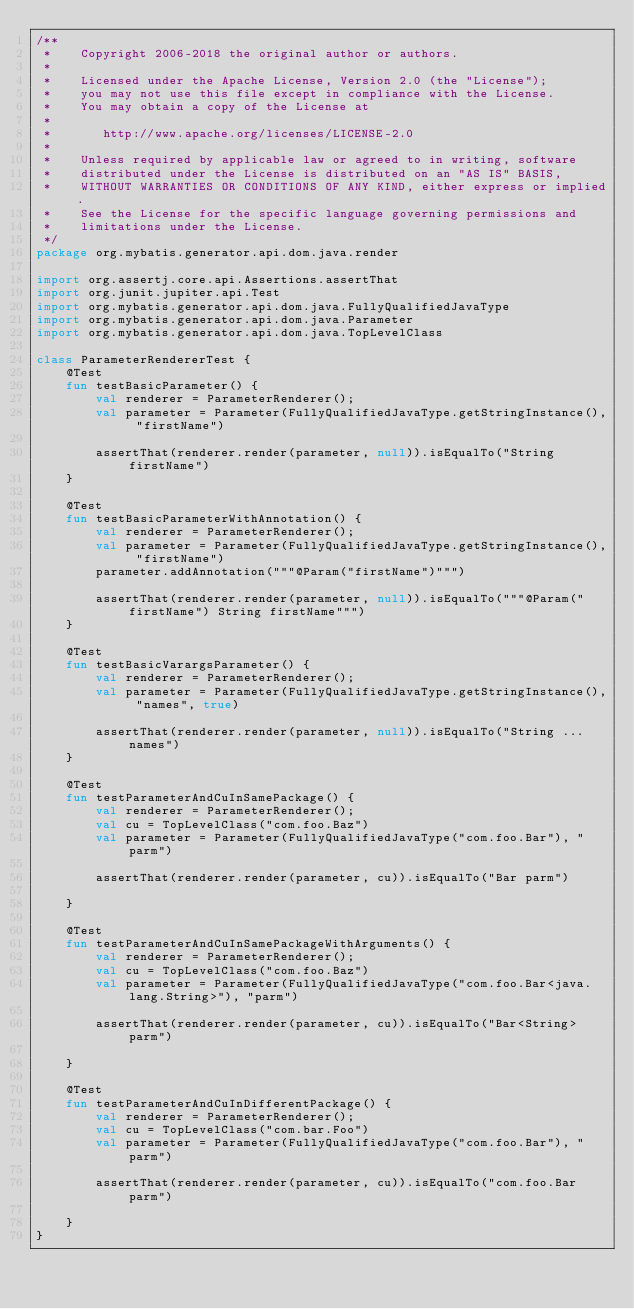Convert code to text. <code><loc_0><loc_0><loc_500><loc_500><_Kotlin_>/**
 *    Copyright 2006-2018 the original author or authors.
 *
 *    Licensed under the Apache License, Version 2.0 (the "License");
 *    you may not use this file except in compliance with the License.
 *    You may obtain a copy of the License at
 *
 *       http://www.apache.org/licenses/LICENSE-2.0
 *
 *    Unless required by applicable law or agreed to in writing, software
 *    distributed under the License is distributed on an "AS IS" BASIS,
 *    WITHOUT WARRANTIES OR CONDITIONS OF ANY KIND, either express or implied.
 *    See the License for the specific language governing permissions and
 *    limitations under the License.
 */
package org.mybatis.generator.api.dom.java.render

import org.assertj.core.api.Assertions.assertThat
import org.junit.jupiter.api.Test
import org.mybatis.generator.api.dom.java.FullyQualifiedJavaType
import org.mybatis.generator.api.dom.java.Parameter
import org.mybatis.generator.api.dom.java.TopLevelClass

class ParameterRendererTest {
    @Test
    fun testBasicParameter() {
        val renderer = ParameterRenderer();
        val parameter = Parameter(FullyQualifiedJavaType.getStringInstance(), "firstName")

        assertThat(renderer.render(parameter, null)).isEqualTo("String firstName")
    }

    @Test
    fun testBasicParameterWithAnnotation() {
        val renderer = ParameterRenderer();
        val parameter = Parameter(FullyQualifiedJavaType.getStringInstance(), "firstName")
        parameter.addAnnotation("""@Param("firstName")""")

        assertThat(renderer.render(parameter, null)).isEqualTo("""@Param("firstName") String firstName""")
    }
	
    @Test
    fun testBasicVarargsParameter() {
        val renderer = ParameterRenderer();
        val parameter = Parameter(FullyQualifiedJavaType.getStringInstance(), "names", true)

        assertThat(renderer.render(parameter, null)).isEqualTo("String ... names")
    }

    @Test
    fun testParameterAndCuInSamePackage() {
        val renderer = ParameterRenderer();
        val cu = TopLevelClass("com.foo.Baz")
        val parameter = Parameter(FullyQualifiedJavaType("com.foo.Bar"), "parm")

        assertThat(renderer.render(parameter, cu)).isEqualTo("Bar parm")
	
    }

    @Test
    fun testParameterAndCuInSamePackageWithArguments() {
        val renderer = ParameterRenderer();
        val cu = TopLevelClass("com.foo.Baz")
        val parameter = Parameter(FullyQualifiedJavaType("com.foo.Bar<java.lang.String>"), "parm")

        assertThat(renderer.render(parameter, cu)).isEqualTo("Bar<String> parm")
	
    }

    @Test
    fun testParameterAndCuInDifferentPackage() {
        val renderer = ParameterRenderer();
        val cu = TopLevelClass("com.bar.Foo")
        val parameter = Parameter(FullyQualifiedJavaType("com.foo.Bar"), "parm")

        assertThat(renderer.render(parameter, cu)).isEqualTo("com.foo.Bar parm")
	
    }
}</code> 